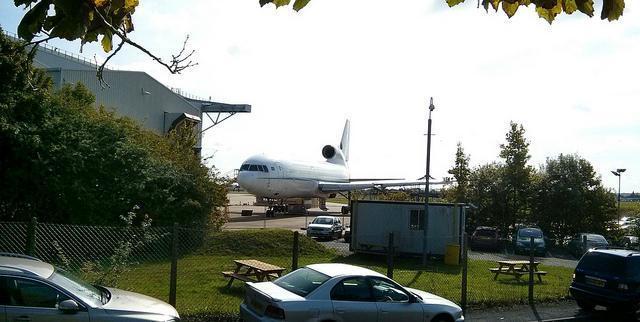How many buildings are visible?
Give a very brief answer. 2. How many cars are there?
Give a very brief answer. 3. How many people are in the room?
Give a very brief answer. 0. 